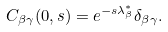Convert formula to latex. <formula><loc_0><loc_0><loc_500><loc_500>C _ { \beta \gamma } ( 0 , s ) = e ^ { - s \lambda ^ { * } _ { \beta } } \delta _ { \beta \gamma } .</formula> 